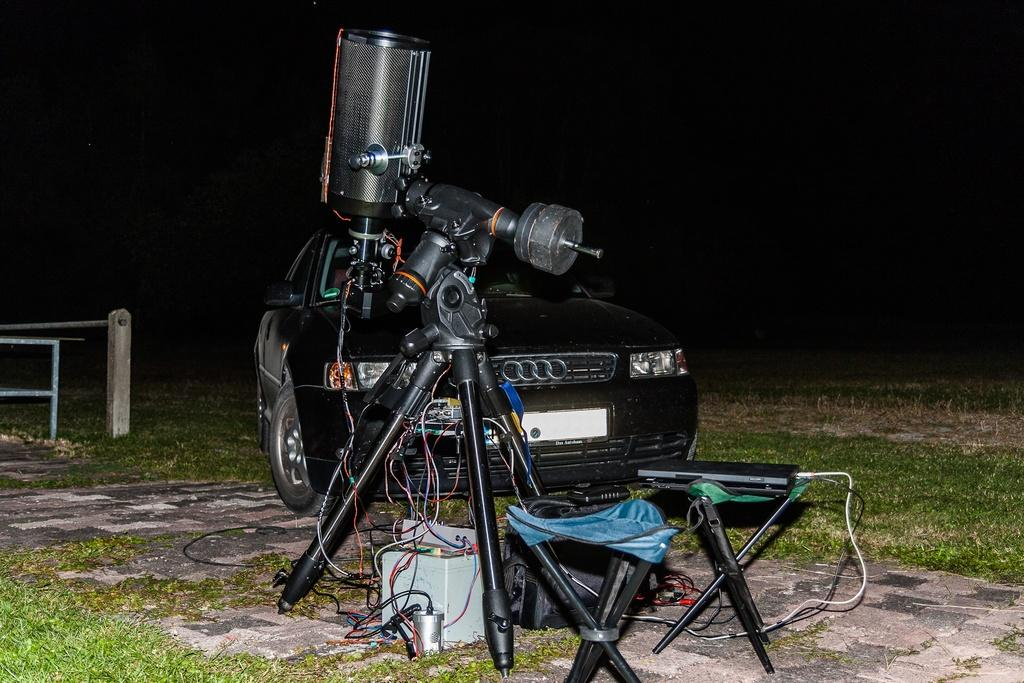What type of electronic device can be seen in the image? There is an electronic device in the image, which is a laptop. What is connected to the electronic device in the image? Cables are present in the image and are connected to the laptop. What type of furniture is in the image? There are stools in the image. Where are the cables located in the image? The cables are on the ground in the image. What is visible in the background of the image? There is a car in the background of the image. Can you describe the location of the car in the image? The car is on the grass in the background of the image. What is on the left side of the image? There are poles on the left side of the image. What type of animal is solving a riddle while wearing a suit in the image? There is no animal, riddle, or suit present in the image. 